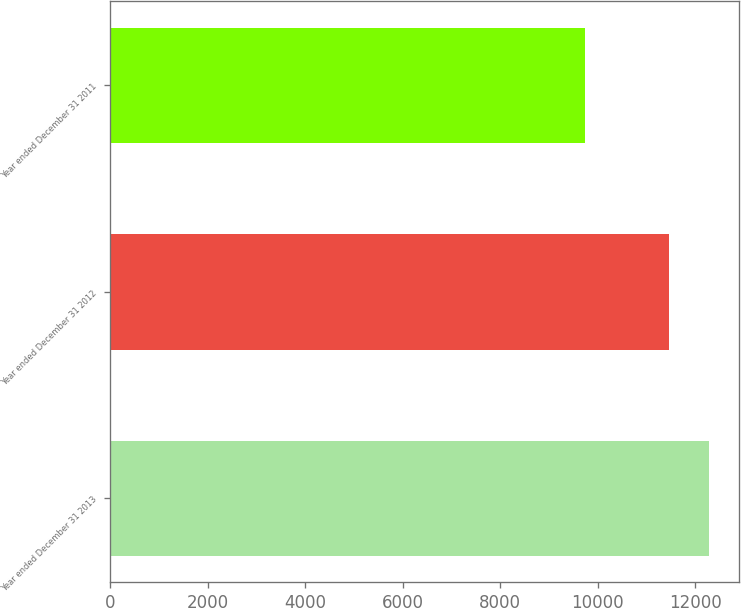Convert chart. <chart><loc_0><loc_0><loc_500><loc_500><bar_chart><fcel>Year ended December 31 2013<fcel>Year ended December 31 2012<fcel>Year ended December 31 2011<nl><fcel>12278<fcel>11461<fcel>9738<nl></chart> 